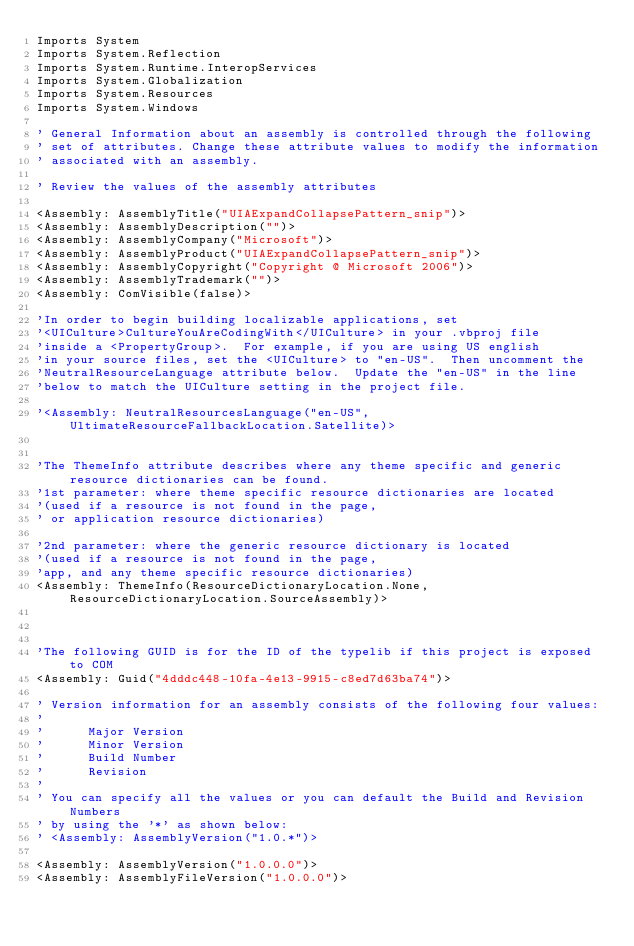Convert code to text. <code><loc_0><loc_0><loc_500><loc_500><_VisualBasic_>Imports System
Imports System.Reflection
Imports System.Runtime.InteropServices
Imports System.Globalization
Imports System.Resources
Imports System.Windows

' General Information about an assembly is controlled through the following 
' set of attributes. Change these attribute values to modify the information
' associated with an assembly.

' Review the values of the assembly attributes

<Assembly: AssemblyTitle("UIAExpandCollapsePattern_snip")> 
<Assembly: AssemblyDescription("")> 
<Assembly: AssemblyCompany("Microsoft")> 
<Assembly: AssemblyProduct("UIAExpandCollapsePattern_snip")> 
<Assembly: AssemblyCopyright("Copyright @ Microsoft 2006")> 
<Assembly: AssemblyTrademark("")> 
<Assembly: ComVisible(false)>

'In order to begin building localizable applications, set 
'<UICulture>CultureYouAreCodingWith</UICulture> in your .vbproj file
'inside a <PropertyGroup>.  For example, if you are using US english 
'in your source files, set the <UICulture> to "en-US".  Then uncomment the
'NeutralResourceLanguage attribute below.  Update the "en-US" in the line
'below to match the UICulture setting in the project file.

'<Assembly: NeutralResourcesLanguage("en-US", UltimateResourceFallbackLocation.Satellite)> 


'The ThemeInfo attribute describes where any theme specific and generic resource dictionaries can be found.
'1st parameter: where theme specific resource dictionaries are located
'(used if a resource is not found in the page, 
' or application resource dictionaries)

'2nd parameter: where the generic resource dictionary is located
'(used if a resource is not found in the page, 
'app, and any theme specific resource dictionaries)
<Assembly: ThemeInfo(ResourceDictionaryLocation.None, ResourceDictionaryLocation.SourceAssembly)>



'The following GUID is for the ID of the typelib if this project is exposed to COM
<Assembly: Guid("4dddc448-10fa-4e13-9915-c8ed7d63ba74")> 

' Version information for an assembly consists of the following four values:
'
'      Major Version
'      Minor Version 
'      Build Number
'      Revision
'
' You can specify all the values or you can default the Build and Revision Numbers 
' by using the '*' as shown below:
' <Assembly: AssemblyVersion("1.0.*")> 

<Assembly: AssemblyVersion("1.0.0.0")> 
<Assembly: AssemblyFileVersion("1.0.0.0")> 
</code> 